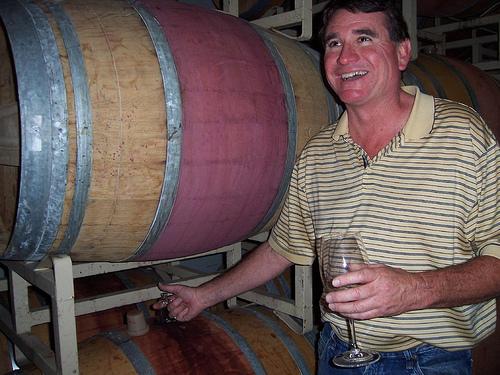What is the barrel made of?
Short answer required. Wood. What is the man drinking?
Concise answer only. Wine. Where was this photo taken place?
Concise answer only. Winery. 